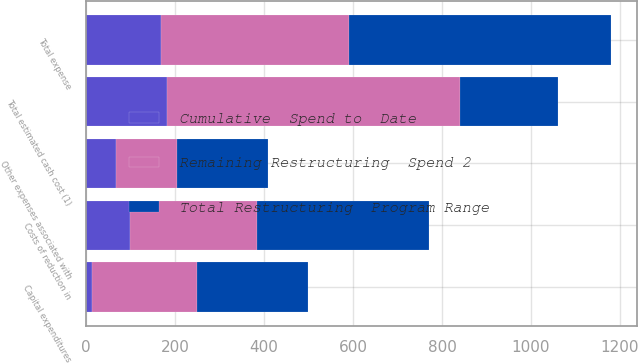Convert chart. <chart><loc_0><loc_0><loc_500><loc_500><stacked_bar_chart><ecel><fcel>Costs of reduction in<fcel>Other expenses associated with<fcel>Total expense<fcel>Capital expenditures<fcel>Total estimated cash cost (1)<nl><fcel>Total Restructuring  Program Range<fcel>385<fcel>205<fcel>590<fcel>250<fcel>220.5<nl><fcel>Remaining Restructuring  Spend 2<fcel>285<fcel>137<fcel>422<fcel>236<fcel>658<nl><fcel>Cumulative  Spend to  Date<fcel>100<fcel>68<fcel>168<fcel>14<fcel>182<nl></chart> 